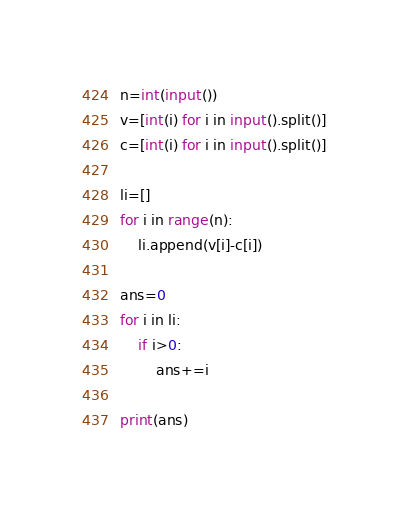<code> <loc_0><loc_0><loc_500><loc_500><_Python_>n=int(input())
v=[int(i) for i in input().split()]
c=[int(i) for i in input().split()]

li=[]
for i in range(n):
    li.append(v[i]-c[i])

ans=0
for i in li:
    if i>0:
        ans+=i

print(ans)
</code> 